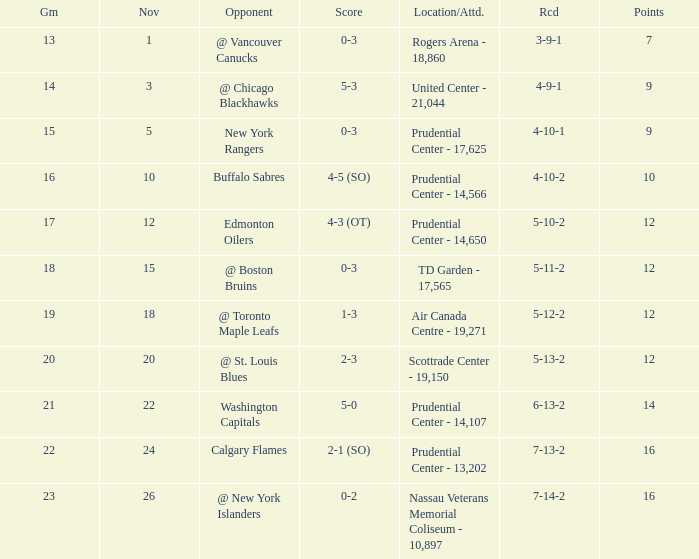What is the maximum number of points? 16.0. Parse the full table. {'header': ['Gm', 'Nov', 'Opponent', 'Score', 'Location/Attd.', 'Rcd', 'Points'], 'rows': [['13', '1', '@ Vancouver Canucks', '0-3', 'Rogers Arena - 18,860', '3-9-1', '7'], ['14', '3', '@ Chicago Blackhawks', '5-3', 'United Center - 21,044', '4-9-1', '9'], ['15', '5', 'New York Rangers', '0-3', 'Prudential Center - 17,625', '4-10-1', '9'], ['16', '10', 'Buffalo Sabres', '4-5 (SO)', 'Prudential Center - 14,566', '4-10-2', '10'], ['17', '12', 'Edmonton Oilers', '4-3 (OT)', 'Prudential Center - 14,650', '5-10-2', '12'], ['18', '15', '@ Boston Bruins', '0-3', 'TD Garden - 17,565', '5-11-2', '12'], ['19', '18', '@ Toronto Maple Leafs', '1-3', 'Air Canada Centre - 19,271', '5-12-2', '12'], ['20', '20', '@ St. Louis Blues', '2-3', 'Scottrade Center - 19,150', '5-13-2', '12'], ['21', '22', 'Washington Capitals', '5-0', 'Prudential Center - 14,107', '6-13-2', '14'], ['22', '24', 'Calgary Flames', '2-1 (SO)', 'Prudential Center - 13,202', '7-13-2', '16'], ['23', '26', '@ New York Islanders', '0-2', 'Nassau Veterans Memorial Coliseum - 10,897', '7-14-2', '16']]} 